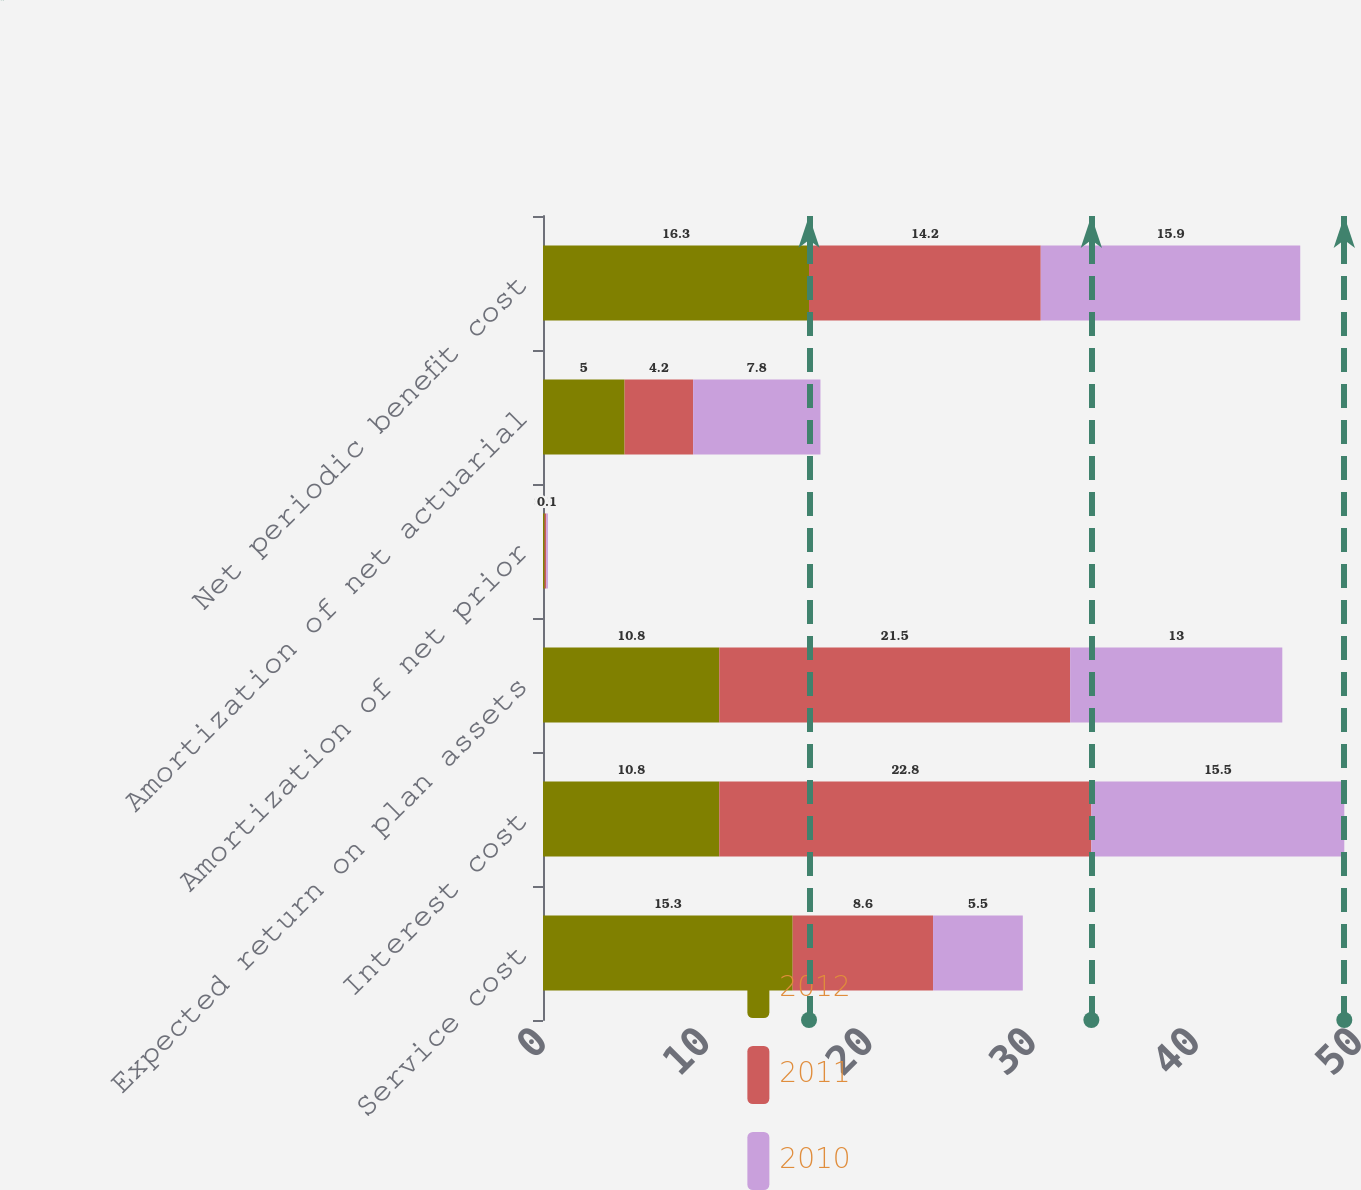<chart> <loc_0><loc_0><loc_500><loc_500><stacked_bar_chart><ecel><fcel>Service cost<fcel>Interest cost<fcel>Expected return on plan assets<fcel>Amortization of net prior<fcel>Amortization of net actuarial<fcel>Net periodic benefit cost<nl><fcel>2012<fcel>15.3<fcel>10.8<fcel>10.8<fcel>0.1<fcel>5<fcel>16.3<nl><fcel>2011<fcel>8.6<fcel>22.8<fcel>21.5<fcel>0.1<fcel>4.2<fcel>14.2<nl><fcel>2010<fcel>5.5<fcel>15.5<fcel>13<fcel>0.1<fcel>7.8<fcel>15.9<nl></chart> 